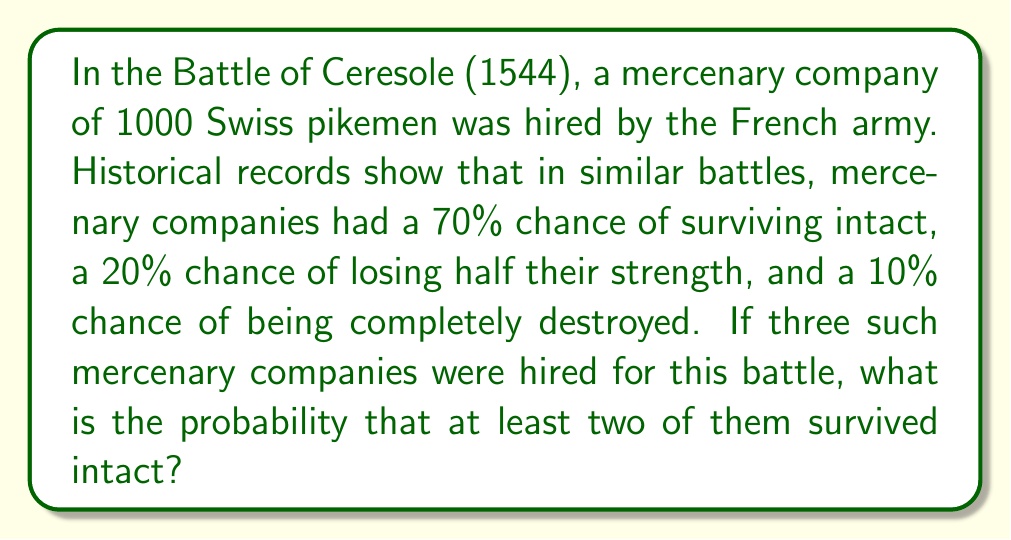Help me with this question. To solve this problem, we'll use the concept of probability and the binomial distribution.

Let's define our events:
- A: A mercenary company survives intact (probability = 0.70)
- B: At least two out of three companies survive intact

We need to calculate P(B). This can be done by calculating the probability of exactly 2 or exactly 3 companies surviving intact.

1) Probability of exactly 3 companies surviving intact:
   $P(\text{3 intact}) = 0.70^3 = 0.343$

2) Probability of exactly 2 companies surviving intact:
   $P(\text{2 intact}) = \binom{3}{2} \times 0.70^2 \times 0.30^1 = 3 \times 0.70^2 \times 0.30 = 0.441$

3) The probability of at least 2 companies surviving intact is the sum of these probabilities:
   $P(B) = P(\text{3 intact}) + P(\text{2 intact}) = 0.343 + 0.441 = 0.784$

Therefore, the probability that at least two of the three mercenary companies survived intact is 0.784 or 78.4%.
Answer: 0.784 or 78.4% 